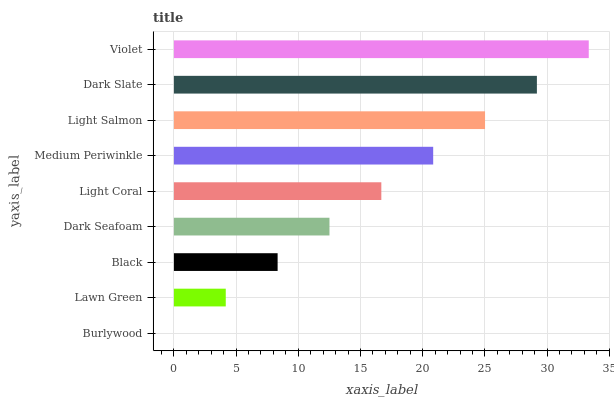Is Burlywood the minimum?
Answer yes or no. Yes. Is Violet the maximum?
Answer yes or no. Yes. Is Lawn Green the minimum?
Answer yes or no. No. Is Lawn Green the maximum?
Answer yes or no. No. Is Lawn Green greater than Burlywood?
Answer yes or no. Yes. Is Burlywood less than Lawn Green?
Answer yes or no. Yes. Is Burlywood greater than Lawn Green?
Answer yes or no. No. Is Lawn Green less than Burlywood?
Answer yes or no. No. Is Light Coral the high median?
Answer yes or no. Yes. Is Light Coral the low median?
Answer yes or no. Yes. Is Light Salmon the high median?
Answer yes or no. No. Is Black the low median?
Answer yes or no. No. 